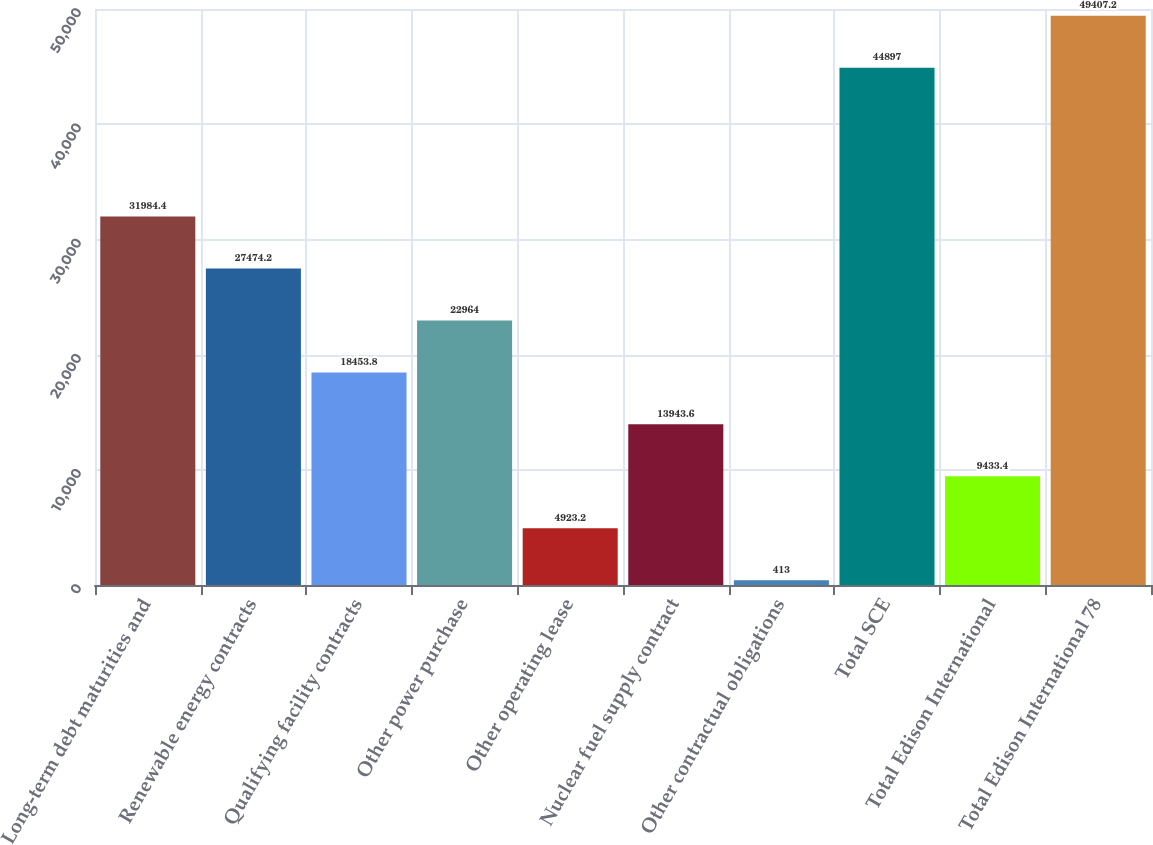Convert chart. <chart><loc_0><loc_0><loc_500><loc_500><bar_chart><fcel>Long-term debt maturities and<fcel>Renewable energy contracts<fcel>Qualifying facility contracts<fcel>Other power purchase<fcel>Other operating lease<fcel>Nuclear fuel supply contract<fcel>Other contractual obligations<fcel>Total SCE<fcel>Total Edison International<fcel>Total Edison International 78<nl><fcel>31984.4<fcel>27474.2<fcel>18453.8<fcel>22964<fcel>4923.2<fcel>13943.6<fcel>413<fcel>44897<fcel>9433.4<fcel>49407.2<nl></chart> 